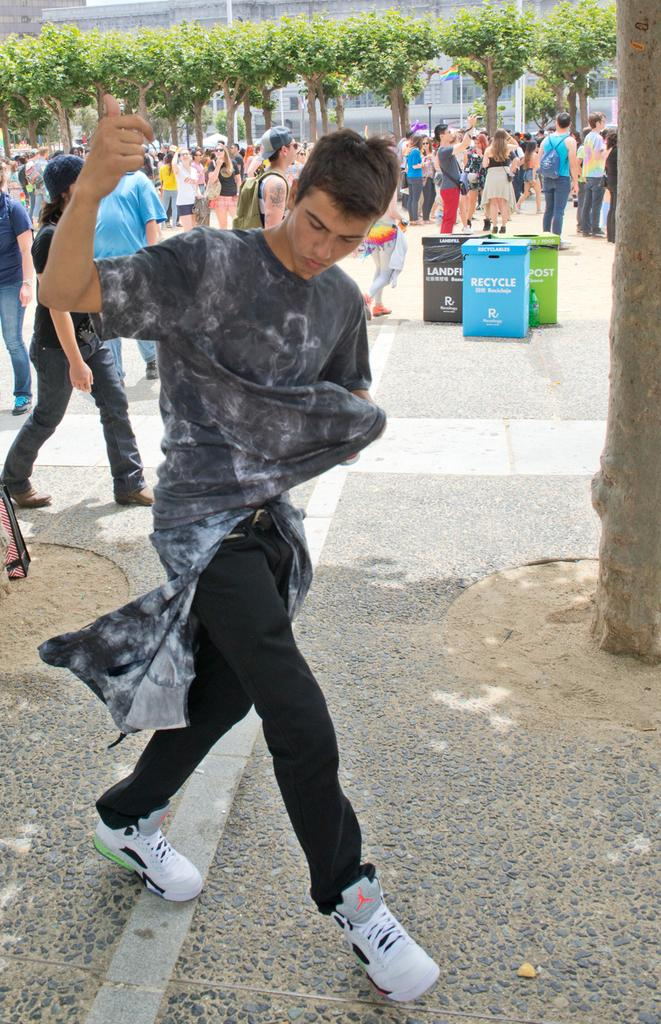What are the people in the image doing? There is a group of people standing on the ground in the image. What else can be seen in the image besides the people? Containers and the bark of a tree are visible in the image. How many trees are present in the image? There is a group of trees in the image. What type of structures can be seen in the image? There are buildings visible in the image. What type of feeling can be seen in the fog in the image? There is no fog present in the image, so it is not possible to determine any feelings associated with it. 